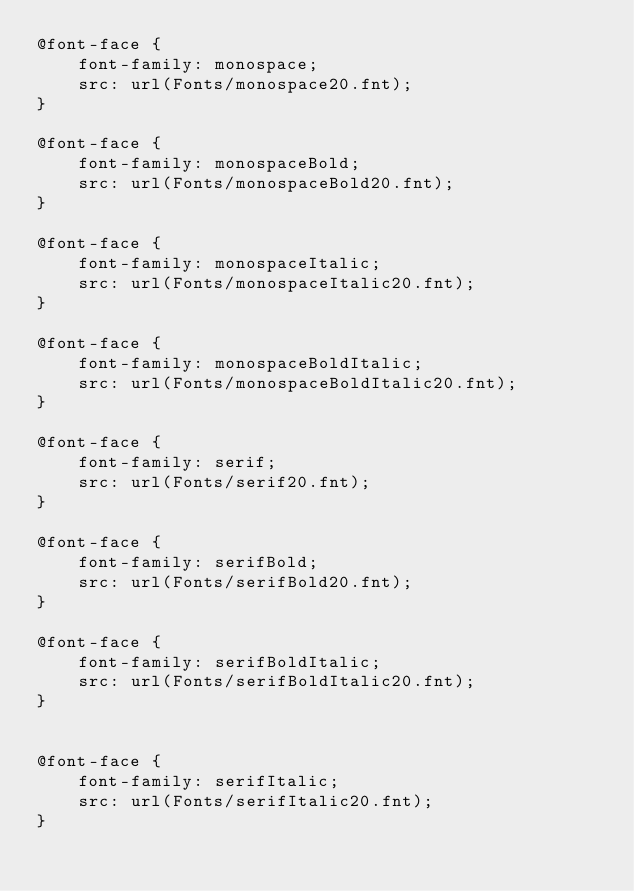<code> <loc_0><loc_0><loc_500><loc_500><_CSS_>@font-face {
	font-family: monospace;
	src: url(Fonts/monospace20.fnt);
}

@font-face {
	font-family: monospaceBold;
	src: url(Fonts/monospaceBold20.fnt);
}

@font-face {
	font-family: monospaceItalic;
	src: url(Fonts/monospaceItalic20.fnt);
}

@font-face {
	font-family: monospaceBoldItalic;
	src: url(Fonts/monospaceBoldItalic20.fnt);
}

@font-face {
	font-family: serif;
	src: url(Fonts/serif20.fnt);
}

@font-face {
	font-family: serifBold;
	src: url(Fonts/serifBold20.fnt);
}

@font-face {
	font-family: serifBoldItalic;
	src: url(Fonts/serifBoldItalic20.fnt);
}


@font-face {
	font-family: serifItalic;
	src: url(Fonts/serifItalic20.fnt);
}</code> 